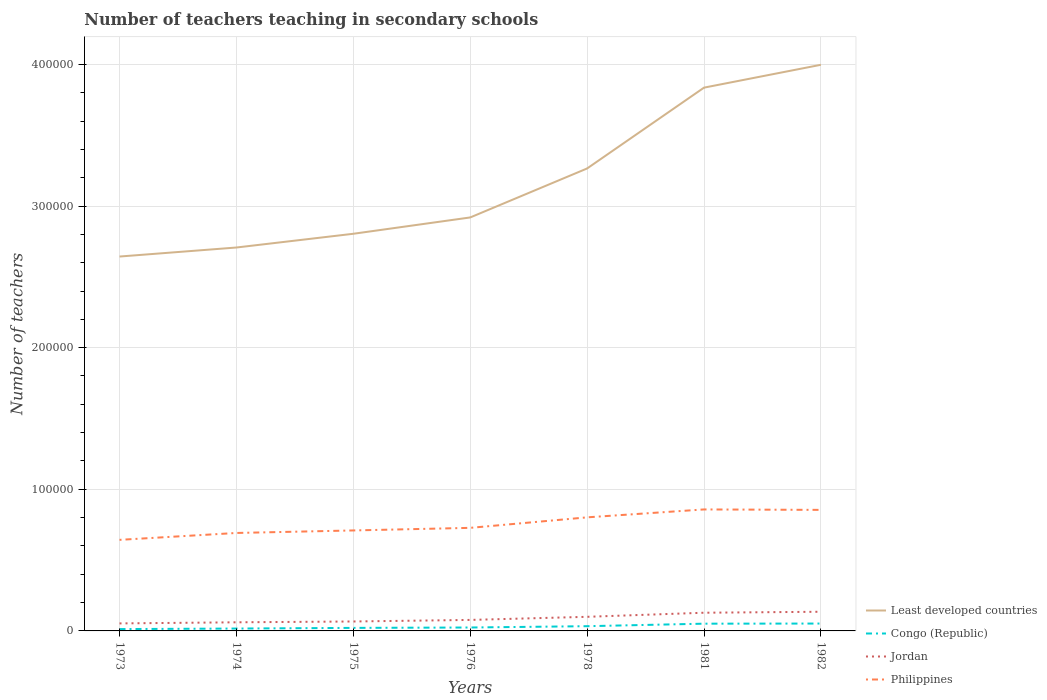Is the number of lines equal to the number of legend labels?
Provide a short and direct response. Yes. Across all years, what is the maximum number of teachers teaching in secondary schools in Congo (Republic)?
Your response must be concise. 1302. What is the total number of teachers teaching in secondary schools in Least developed countries in the graph?
Give a very brief answer. -1.61e+04. What is the difference between the highest and the second highest number of teachers teaching in secondary schools in Jordan?
Give a very brief answer. 8230. What is the difference between the highest and the lowest number of teachers teaching in secondary schools in Jordan?
Your answer should be very brief. 3. How many lines are there?
Offer a terse response. 4. What is the difference between two consecutive major ticks on the Y-axis?
Make the answer very short. 1.00e+05. Does the graph contain any zero values?
Ensure brevity in your answer.  No. Does the graph contain grids?
Offer a terse response. Yes. Where does the legend appear in the graph?
Provide a succinct answer. Bottom right. How are the legend labels stacked?
Your response must be concise. Vertical. What is the title of the graph?
Your answer should be very brief. Number of teachers teaching in secondary schools. Does "Upper middle income" appear as one of the legend labels in the graph?
Your answer should be compact. No. What is the label or title of the X-axis?
Your answer should be compact. Years. What is the label or title of the Y-axis?
Provide a succinct answer. Number of teachers. What is the Number of teachers of Least developed countries in 1973?
Give a very brief answer. 2.64e+05. What is the Number of teachers of Congo (Republic) in 1973?
Your answer should be compact. 1302. What is the Number of teachers in Jordan in 1973?
Your answer should be compact. 5309. What is the Number of teachers in Philippines in 1973?
Your answer should be compact. 6.43e+04. What is the Number of teachers of Least developed countries in 1974?
Ensure brevity in your answer.  2.71e+05. What is the Number of teachers of Congo (Republic) in 1974?
Offer a terse response. 1681. What is the Number of teachers in Jordan in 1974?
Offer a very short reply. 6088. What is the Number of teachers of Philippines in 1974?
Keep it short and to the point. 6.92e+04. What is the Number of teachers in Least developed countries in 1975?
Your answer should be very brief. 2.80e+05. What is the Number of teachers in Congo (Republic) in 1975?
Offer a terse response. 2143. What is the Number of teachers in Jordan in 1975?
Provide a succinct answer. 6666. What is the Number of teachers in Philippines in 1975?
Your response must be concise. 7.09e+04. What is the Number of teachers in Least developed countries in 1976?
Give a very brief answer. 2.92e+05. What is the Number of teachers in Congo (Republic) in 1976?
Keep it short and to the point. 2413. What is the Number of teachers of Jordan in 1976?
Ensure brevity in your answer.  7768. What is the Number of teachers of Philippines in 1976?
Keep it short and to the point. 7.28e+04. What is the Number of teachers in Least developed countries in 1978?
Offer a very short reply. 3.27e+05. What is the Number of teachers in Congo (Republic) in 1978?
Make the answer very short. 3344. What is the Number of teachers in Jordan in 1978?
Make the answer very short. 9962. What is the Number of teachers in Philippines in 1978?
Your answer should be very brief. 8.02e+04. What is the Number of teachers in Least developed countries in 1981?
Your answer should be compact. 3.84e+05. What is the Number of teachers in Congo (Republic) in 1981?
Give a very brief answer. 5117. What is the Number of teachers in Jordan in 1981?
Your answer should be very brief. 1.28e+04. What is the Number of teachers in Philippines in 1981?
Offer a terse response. 8.58e+04. What is the Number of teachers in Least developed countries in 1982?
Make the answer very short. 4.00e+05. What is the Number of teachers in Congo (Republic) in 1982?
Your answer should be very brief. 5207. What is the Number of teachers of Jordan in 1982?
Your answer should be very brief. 1.35e+04. What is the Number of teachers in Philippines in 1982?
Your response must be concise. 8.55e+04. Across all years, what is the maximum Number of teachers in Least developed countries?
Your answer should be very brief. 4.00e+05. Across all years, what is the maximum Number of teachers in Congo (Republic)?
Ensure brevity in your answer.  5207. Across all years, what is the maximum Number of teachers in Jordan?
Offer a terse response. 1.35e+04. Across all years, what is the maximum Number of teachers of Philippines?
Make the answer very short. 8.58e+04. Across all years, what is the minimum Number of teachers of Least developed countries?
Your response must be concise. 2.64e+05. Across all years, what is the minimum Number of teachers in Congo (Republic)?
Provide a succinct answer. 1302. Across all years, what is the minimum Number of teachers of Jordan?
Your response must be concise. 5309. Across all years, what is the minimum Number of teachers in Philippines?
Make the answer very short. 6.43e+04. What is the total Number of teachers in Least developed countries in the graph?
Provide a short and direct response. 2.22e+06. What is the total Number of teachers of Congo (Republic) in the graph?
Provide a succinct answer. 2.12e+04. What is the total Number of teachers in Jordan in the graph?
Your answer should be very brief. 6.22e+04. What is the total Number of teachers of Philippines in the graph?
Your answer should be compact. 5.29e+05. What is the difference between the Number of teachers in Least developed countries in 1973 and that in 1974?
Keep it short and to the point. -6379.69. What is the difference between the Number of teachers in Congo (Republic) in 1973 and that in 1974?
Ensure brevity in your answer.  -379. What is the difference between the Number of teachers in Jordan in 1973 and that in 1974?
Your answer should be compact. -779. What is the difference between the Number of teachers in Philippines in 1973 and that in 1974?
Give a very brief answer. -4864. What is the difference between the Number of teachers of Least developed countries in 1973 and that in 1975?
Your answer should be compact. -1.61e+04. What is the difference between the Number of teachers in Congo (Republic) in 1973 and that in 1975?
Your response must be concise. -841. What is the difference between the Number of teachers of Jordan in 1973 and that in 1975?
Provide a succinct answer. -1357. What is the difference between the Number of teachers in Philippines in 1973 and that in 1975?
Offer a very short reply. -6644. What is the difference between the Number of teachers in Least developed countries in 1973 and that in 1976?
Make the answer very short. -2.76e+04. What is the difference between the Number of teachers of Congo (Republic) in 1973 and that in 1976?
Provide a succinct answer. -1111. What is the difference between the Number of teachers in Jordan in 1973 and that in 1976?
Provide a short and direct response. -2459. What is the difference between the Number of teachers of Philippines in 1973 and that in 1976?
Provide a succinct answer. -8475. What is the difference between the Number of teachers in Least developed countries in 1973 and that in 1978?
Your answer should be compact. -6.22e+04. What is the difference between the Number of teachers of Congo (Republic) in 1973 and that in 1978?
Ensure brevity in your answer.  -2042. What is the difference between the Number of teachers in Jordan in 1973 and that in 1978?
Offer a terse response. -4653. What is the difference between the Number of teachers of Philippines in 1973 and that in 1978?
Your response must be concise. -1.59e+04. What is the difference between the Number of teachers in Least developed countries in 1973 and that in 1981?
Your response must be concise. -1.19e+05. What is the difference between the Number of teachers of Congo (Republic) in 1973 and that in 1981?
Offer a terse response. -3815. What is the difference between the Number of teachers of Jordan in 1973 and that in 1981?
Your answer should be very brief. -7539. What is the difference between the Number of teachers of Philippines in 1973 and that in 1981?
Keep it short and to the point. -2.15e+04. What is the difference between the Number of teachers of Least developed countries in 1973 and that in 1982?
Your answer should be very brief. -1.35e+05. What is the difference between the Number of teachers of Congo (Republic) in 1973 and that in 1982?
Your answer should be very brief. -3905. What is the difference between the Number of teachers in Jordan in 1973 and that in 1982?
Offer a very short reply. -8230. What is the difference between the Number of teachers in Philippines in 1973 and that in 1982?
Make the answer very short. -2.12e+04. What is the difference between the Number of teachers in Least developed countries in 1974 and that in 1975?
Keep it short and to the point. -9694.94. What is the difference between the Number of teachers in Congo (Republic) in 1974 and that in 1975?
Ensure brevity in your answer.  -462. What is the difference between the Number of teachers in Jordan in 1974 and that in 1975?
Offer a very short reply. -578. What is the difference between the Number of teachers in Philippines in 1974 and that in 1975?
Make the answer very short. -1780. What is the difference between the Number of teachers of Least developed countries in 1974 and that in 1976?
Your answer should be very brief. -2.12e+04. What is the difference between the Number of teachers of Congo (Republic) in 1974 and that in 1976?
Your answer should be compact. -732. What is the difference between the Number of teachers in Jordan in 1974 and that in 1976?
Ensure brevity in your answer.  -1680. What is the difference between the Number of teachers of Philippines in 1974 and that in 1976?
Keep it short and to the point. -3611. What is the difference between the Number of teachers in Least developed countries in 1974 and that in 1978?
Your response must be concise. -5.58e+04. What is the difference between the Number of teachers of Congo (Republic) in 1974 and that in 1978?
Your response must be concise. -1663. What is the difference between the Number of teachers of Jordan in 1974 and that in 1978?
Keep it short and to the point. -3874. What is the difference between the Number of teachers in Philippines in 1974 and that in 1978?
Ensure brevity in your answer.  -1.10e+04. What is the difference between the Number of teachers in Least developed countries in 1974 and that in 1981?
Ensure brevity in your answer.  -1.13e+05. What is the difference between the Number of teachers of Congo (Republic) in 1974 and that in 1981?
Your answer should be compact. -3436. What is the difference between the Number of teachers of Jordan in 1974 and that in 1981?
Offer a terse response. -6760. What is the difference between the Number of teachers of Philippines in 1974 and that in 1981?
Your answer should be compact. -1.66e+04. What is the difference between the Number of teachers of Least developed countries in 1974 and that in 1982?
Provide a succinct answer. -1.29e+05. What is the difference between the Number of teachers in Congo (Republic) in 1974 and that in 1982?
Your answer should be compact. -3526. What is the difference between the Number of teachers in Jordan in 1974 and that in 1982?
Your answer should be compact. -7451. What is the difference between the Number of teachers in Philippines in 1974 and that in 1982?
Ensure brevity in your answer.  -1.63e+04. What is the difference between the Number of teachers of Least developed countries in 1975 and that in 1976?
Offer a very short reply. -1.15e+04. What is the difference between the Number of teachers of Congo (Republic) in 1975 and that in 1976?
Keep it short and to the point. -270. What is the difference between the Number of teachers in Jordan in 1975 and that in 1976?
Your answer should be very brief. -1102. What is the difference between the Number of teachers in Philippines in 1975 and that in 1976?
Your response must be concise. -1831. What is the difference between the Number of teachers of Least developed countries in 1975 and that in 1978?
Offer a terse response. -4.61e+04. What is the difference between the Number of teachers of Congo (Republic) in 1975 and that in 1978?
Your response must be concise. -1201. What is the difference between the Number of teachers in Jordan in 1975 and that in 1978?
Provide a succinct answer. -3296. What is the difference between the Number of teachers in Philippines in 1975 and that in 1978?
Ensure brevity in your answer.  -9245. What is the difference between the Number of teachers of Least developed countries in 1975 and that in 1981?
Offer a terse response. -1.03e+05. What is the difference between the Number of teachers in Congo (Republic) in 1975 and that in 1981?
Provide a succinct answer. -2974. What is the difference between the Number of teachers in Jordan in 1975 and that in 1981?
Your answer should be compact. -6182. What is the difference between the Number of teachers in Philippines in 1975 and that in 1981?
Ensure brevity in your answer.  -1.48e+04. What is the difference between the Number of teachers in Least developed countries in 1975 and that in 1982?
Provide a short and direct response. -1.19e+05. What is the difference between the Number of teachers in Congo (Republic) in 1975 and that in 1982?
Your answer should be compact. -3064. What is the difference between the Number of teachers of Jordan in 1975 and that in 1982?
Your response must be concise. -6873. What is the difference between the Number of teachers in Philippines in 1975 and that in 1982?
Make the answer very short. -1.45e+04. What is the difference between the Number of teachers of Least developed countries in 1976 and that in 1978?
Ensure brevity in your answer.  -3.46e+04. What is the difference between the Number of teachers in Congo (Republic) in 1976 and that in 1978?
Offer a terse response. -931. What is the difference between the Number of teachers in Jordan in 1976 and that in 1978?
Give a very brief answer. -2194. What is the difference between the Number of teachers of Philippines in 1976 and that in 1978?
Provide a short and direct response. -7414. What is the difference between the Number of teachers of Least developed countries in 1976 and that in 1981?
Make the answer very short. -9.17e+04. What is the difference between the Number of teachers of Congo (Republic) in 1976 and that in 1981?
Offer a very short reply. -2704. What is the difference between the Number of teachers of Jordan in 1976 and that in 1981?
Your response must be concise. -5080. What is the difference between the Number of teachers of Philippines in 1976 and that in 1981?
Give a very brief answer. -1.30e+04. What is the difference between the Number of teachers of Least developed countries in 1976 and that in 1982?
Ensure brevity in your answer.  -1.08e+05. What is the difference between the Number of teachers of Congo (Republic) in 1976 and that in 1982?
Ensure brevity in your answer.  -2794. What is the difference between the Number of teachers in Jordan in 1976 and that in 1982?
Provide a succinct answer. -5771. What is the difference between the Number of teachers of Philippines in 1976 and that in 1982?
Keep it short and to the point. -1.27e+04. What is the difference between the Number of teachers of Least developed countries in 1978 and that in 1981?
Make the answer very short. -5.71e+04. What is the difference between the Number of teachers in Congo (Republic) in 1978 and that in 1981?
Give a very brief answer. -1773. What is the difference between the Number of teachers in Jordan in 1978 and that in 1981?
Make the answer very short. -2886. What is the difference between the Number of teachers of Philippines in 1978 and that in 1981?
Provide a short and direct response. -5587. What is the difference between the Number of teachers of Least developed countries in 1978 and that in 1982?
Offer a terse response. -7.32e+04. What is the difference between the Number of teachers of Congo (Republic) in 1978 and that in 1982?
Ensure brevity in your answer.  -1863. What is the difference between the Number of teachers in Jordan in 1978 and that in 1982?
Keep it short and to the point. -3577. What is the difference between the Number of teachers in Philippines in 1978 and that in 1982?
Your answer should be compact. -5273. What is the difference between the Number of teachers of Least developed countries in 1981 and that in 1982?
Give a very brief answer. -1.61e+04. What is the difference between the Number of teachers in Congo (Republic) in 1981 and that in 1982?
Make the answer very short. -90. What is the difference between the Number of teachers of Jordan in 1981 and that in 1982?
Provide a short and direct response. -691. What is the difference between the Number of teachers of Philippines in 1981 and that in 1982?
Ensure brevity in your answer.  314. What is the difference between the Number of teachers of Least developed countries in 1973 and the Number of teachers of Congo (Republic) in 1974?
Provide a succinct answer. 2.63e+05. What is the difference between the Number of teachers in Least developed countries in 1973 and the Number of teachers in Jordan in 1974?
Provide a succinct answer. 2.58e+05. What is the difference between the Number of teachers in Least developed countries in 1973 and the Number of teachers in Philippines in 1974?
Offer a very short reply. 1.95e+05. What is the difference between the Number of teachers of Congo (Republic) in 1973 and the Number of teachers of Jordan in 1974?
Provide a succinct answer. -4786. What is the difference between the Number of teachers of Congo (Republic) in 1973 and the Number of teachers of Philippines in 1974?
Make the answer very short. -6.79e+04. What is the difference between the Number of teachers in Jordan in 1973 and the Number of teachers in Philippines in 1974?
Keep it short and to the point. -6.39e+04. What is the difference between the Number of teachers in Least developed countries in 1973 and the Number of teachers in Congo (Republic) in 1975?
Your response must be concise. 2.62e+05. What is the difference between the Number of teachers of Least developed countries in 1973 and the Number of teachers of Jordan in 1975?
Make the answer very short. 2.58e+05. What is the difference between the Number of teachers in Least developed countries in 1973 and the Number of teachers in Philippines in 1975?
Give a very brief answer. 1.93e+05. What is the difference between the Number of teachers of Congo (Republic) in 1973 and the Number of teachers of Jordan in 1975?
Your response must be concise. -5364. What is the difference between the Number of teachers of Congo (Republic) in 1973 and the Number of teachers of Philippines in 1975?
Your answer should be compact. -6.96e+04. What is the difference between the Number of teachers of Jordan in 1973 and the Number of teachers of Philippines in 1975?
Make the answer very short. -6.56e+04. What is the difference between the Number of teachers in Least developed countries in 1973 and the Number of teachers in Congo (Republic) in 1976?
Your answer should be very brief. 2.62e+05. What is the difference between the Number of teachers of Least developed countries in 1973 and the Number of teachers of Jordan in 1976?
Your answer should be very brief. 2.57e+05. What is the difference between the Number of teachers in Least developed countries in 1973 and the Number of teachers in Philippines in 1976?
Provide a short and direct response. 1.92e+05. What is the difference between the Number of teachers of Congo (Republic) in 1973 and the Number of teachers of Jordan in 1976?
Your answer should be compact. -6466. What is the difference between the Number of teachers in Congo (Republic) in 1973 and the Number of teachers in Philippines in 1976?
Your answer should be compact. -7.15e+04. What is the difference between the Number of teachers of Jordan in 1973 and the Number of teachers of Philippines in 1976?
Your answer should be compact. -6.75e+04. What is the difference between the Number of teachers of Least developed countries in 1973 and the Number of teachers of Congo (Republic) in 1978?
Make the answer very short. 2.61e+05. What is the difference between the Number of teachers in Least developed countries in 1973 and the Number of teachers in Jordan in 1978?
Ensure brevity in your answer.  2.54e+05. What is the difference between the Number of teachers of Least developed countries in 1973 and the Number of teachers of Philippines in 1978?
Make the answer very short. 1.84e+05. What is the difference between the Number of teachers in Congo (Republic) in 1973 and the Number of teachers in Jordan in 1978?
Offer a very short reply. -8660. What is the difference between the Number of teachers in Congo (Republic) in 1973 and the Number of teachers in Philippines in 1978?
Offer a terse response. -7.89e+04. What is the difference between the Number of teachers in Jordan in 1973 and the Number of teachers in Philippines in 1978?
Give a very brief answer. -7.49e+04. What is the difference between the Number of teachers of Least developed countries in 1973 and the Number of teachers of Congo (Republic) in 1981?
Make the answer very short. 2.59e+05. What is the difference between the Number of teachers in Least developed countries in 1973 and the Number of teachers in Jordan in 1981?
Ensure brevity in your answer.  2.52e+05. What is the difference between the Number of teachers in Least developed countries in 1973 and the Number of teachers in Philippines in 1981?
Provide a succinct answer. 1.79e+05. What is the difference between the Number of teachers in Congo (Republic) in 1973 and the Number of teachers in Jordan in 1981?
Give a very brief answer. -1.15e+04. What is the difference between the Number of teachers of Congo (Republic) in 1973 and the Number of teachers of Philippines in 1981?
Ensure brevity in your answer.  -8.45e+04. What is the difference between the Number of teachers of Jordan in 1973 and the Number of teachers of Philippines in 1981?
Ensure brevity in your answer.  -8.05e+04. What is the difference between the Number of teachers in Least developed countries in 1973 and the Number of teachers in Congo (Republic) in 1982?
Make the answer very short. 2.59e+05. What is the difference between the Number of teachers of Least developed countries in 1973 and the Number of teachers of Jordan in 1982?
Ensure brevity in your answer.  2.51e+05. What is the difference between the Number of teachers of Least developed countries in 1973 and the Number of teachers of Philippines in 1982?
Provide a succinct answer. 1.79e+05. What is the difference between the Number of teachers of Congo (Republic) in 1973 and the Number of teachers of Jordan in 1982?
Ensure brevity in your answer.  -1.22e+04. What is the difference between the Number of teachers in Congo (Republic) in 1973 and the Number of teachers in Philippines in 1982?
Provide a short and direct response. -8.42e+04. What is the difference between the Number of teachers of Jordan in 1973 and the Number of teachers of Philippines in 1982?
Give a very brief answer. -8.02e+04. What is the difference between the Number of teachers in Least developed countries in 1974 and the Number of teachers in Congo (Republic) in 1975?
Give a very brief answer. 2.69e+05. What is the difference between the Number of teachers in Least developed countries in 1974 and the Number of teachers in Jordan in 1975?
Your response must be concise. 2.64e+05. What is the difference between the Number of teachers of Least developed countries in 1974 and the Number of teachers of Philippines in 1975?
Give a very brief answer. 2.00e+05. What is the difference between the Number of teachers in Congo (Republic) in 1974 and the Number of teachers in Jordan in 1975?
Keep it short and to the point. -4985. What is the difference between the Number of teachers in Congo (Republic) in 1974 and the Number of teachers in Philippines in 1975?
Ensure brevity in your answer.  -6.93e+04. What is the difference between the Number of teachers in Jordan in 1974 and the Number of teachers in Philippines in 1975?
Provide a succinct answer. -6.49e+04. What is the difference between the Number of teachers in Least developed countries in 1974 and the Number of teachers in Congo (Republic) in 1976?
Your answer should be compact. 2.68e+05. What is the difference between the Number of teachers of Least developed countries in 1974 and the Number of teachers of Jordan in 1976?
Provide a succinct answer. 2.63e+05. What is the difference between the Number of teachers of Least developed countries in 1974 and the Number of teachers of Philippines in 1976?
Provide a succinct answer. 1.98e+05. What is the difference between the Number of teachers in Congo (Republic) in 1974 and the Number of teachers in Jordan in 1976?
Your answer should be compact. -6087. What is the difference between the Number of teachers in Congo (Republic) in 1974 and the Number of teachers in Philippines in 1976?
Make the answer very short. -7.11e+04. What is the difference between the Number of teachers in Jordan in 1974 and the Number of teachers in Philippines in 1976?
Offer a very short reply. -6.67e+04. What is the difference between the Number of teachers in Least developed countries in 1974 and the Number of teachers in Congo (Republic) in 1978?
Ensure brevity in your answer.  2.67e+05. What is the difference between the Number of teachers in Least developed countries in 1974 and the Number of teachers in Jordan in 1978?
Keep it short and to the point. 2.61e+05. What is the difference between the Number of teachers in Least developed countries in 1974 and the Number of teachers in Philippines in 1978?
Offer a very short reply. 1.91e+05. What is the difference between the Number of teachers of Congo (Republic) in 1974 and the Number of teachers of Jordan in 1978?
Make the answer very short. -8281. What is the difference between the Number of teachers of Congo (Republic) in 1974 and the Number of teachers of Philippines in 1978?
Give a very brief answer. -7.85e+04. What is the difference between the Number of teachers in Jordan in 1974 and the Number of teachers in Philippines in 1978?
Keep it short and to the point. -7.41e+04. What is the difference between the Number of teachers of Least developed countries in 1974 and the Number of teachers of Congo (Republic) in 1981?
Give a very brief answer. 2.66e+05. What is the difference between the Number of teachers of Least developed countries in 1974 and the Number of teachers of Jordan in 1981?
Your answer should be compact. 2.58e+05. What is the difference between the Number of teachers in Least developed countries in 1974 and the Number of teachers in Philippines in 1981?
Keep it short and to the point. 1.85e+05. What is the difference between the Number of teachers of Congo (Republic) in 1974 and the Number of teachers of Jordan in 1981?
Give a very brief answer. -1.12e+04. What is the difference between the Number of teachers of Congo (Republic) in 1974 and the Number of teachers of Philippines in 1981?
Your response must be concise. -8.41e+04. What is the difference between the Number of teachers of Jordan in 1974 and the Number of teachers of Philippines in 1981?
Your answer should be very brief. -7.97e+04. What is the difference between the Number of teachers in Least developed countries in 1974 and the Number of teachers in Congo (Republic) in 1982?
Ensure brevity in your answer.  2.66e+05. What is the difference between the Number of teachers in Least developed countries in 1974 and the Number of teachers in Jordan in 1982?
Your answer should be compact. 2.57e+05. What is the difference between the Number of teachers of Least developed countries in 1974 and the Number of teachers of Philippines in 1982?
Offer a terse response. 1.85e+05. What is the difference between the Number of teachers of Congo (Republic) in 1974 and the Number of teachers of Jordan in 1982?
Give a very brief answer. -1.19e+04. What is the difference between the Number of teachers of Congo (Republic) in 1974 and the Number of teachers of Philippines in 1982?
Your answer should be very brief. -8.38e+04. What is the difference between the Number of teachers in Jordan in 1974 and the Number of teachers in Philippines in 1982?
Provide a succinct answer. -7.94e+04. What is the difference between the Number of teachers in Least developed countries in 1975 and the Number of teachers in Congo (Republic) in 1976?
Offer a very short reply. 2.78e+05. What is the difference between the Number of teachers in Least developed countries in 1975 and the Number of teachers in Jordan in 1976?
Offer a very short reply. 2.73e+05. What is the difference between the Number of teachers of Least developed countries in 1975 and the Number of teachers of Philippines in 1976?
Make the answer very short. 2.08e+05. What is the difference between the Number of teachers in Congo (Republic) in 1975 and the Number of teachers in Jordan in 1976?
Offer a very short reply. -5625. What is the difference between the Number of teachers of Congo (Republic) in 1975 and the Number of teachers of Philippines in 1976?
Your answer should be compact. -7.06e+04. What is the difference between the Number of teachers of Jordan in 1975 and the Number of teachers of Philippines in 1976?
Offer a terse response. -6.61e+04. What is the difference between the Number of teachers of Least developed countries in 1975 and the Number of teachers of Congo (Republic) in 1978?
Ensure brevity in your answer.  2.77e+05. What is the difference between the Number of teachers in Least developed countries in 1975 and the Number of teachers in Jordan in 1978?
Your answer should be compact. 2.70e+05. What is the difference between the Number of teachers of Least developed countries in 1975 and the Number of teachers of Philippines in 1978?
Your response must be concise. 2.00e+05. What is the difference between the Number of teachers of Congo (Republic) in 1975 and the Number of teachers of Jordan in 1978?
Provide a short and direct response. -7819. What is the difference between the Number of teachers in Congo (Republic) in 1975 and the Number of teachers in Philippines in 1978?
Ensure brevity in your answer.  -7.80e+04. What is the difference between the Number of teachers of Jordan in 1975 and the Number of teachers of Philippines in 1978?
Make the answer very short. -7.35e+04. What is the difference between the Number of teachers of Least developed countries in 1975 and the Number of teachers of Congo (Republic) in 1981?
Make the answer very short. 2.75e+05. What is the difference between the Number of teachers in Least developed countries in 1975 and the Number of teachers in Jordan in 1981?
Ensure brevity in your answer.  2.68e+05. What is the difference between the Number of teachers in Least developed countries in 1975 and the Number of teachers in Philippines in 1981?
Offer a very short reply. 1.95e+05. What is the difference between the Number of teachers in Congo (Republic) in 1975 and the Number of teachers in Jordan in 1981?
Provide a short and direct response. -1.07e+04. What is the difference between the Number of teachers in Congo (Republic) in 1975 and the Number of teachers in Philippines in 1981?
Your answer should be very brief. -8.36e+04. What is the difference between the Number of teachers of Jordan in 1975 and the Number of teachers of Philippines in 1981?
Give a very brief answer. -7.91e+04. What is the difference between the Number of teachers of Least developed countries in 1975 and the Number of teachers of Congo (Republic) in 1982?
Give a very brief answer. 2.75e+05. What is the difference between the Number of teachers of Least developed countries in 1975 and the Number of teachers of Jordan in 1982?
Offer a terse response. 2.67e+05. What is the difference between the Number of teachers of Least developed countries in 1975 and the Number of teachers of Philippines in 1982?
Provide a short and direct response. 1.95e+05. What is the difference between the Number of teachers in Congo (Republic) in 1975 and the Number of teachers in Jordan in 1982?
Offer a terse response. -1.14e+04. What is the difference between the Number of teachers in Congo (Republic) in 1975 and the Number of teachers in Philippines in 1982?
Offer a very short reply. -8.33e+04. What is the difference between the Number of teachers in Jordan in 1975 and the Number of teachers in Philippines in 1982?
Keep it short and to the point. -7.88e+04. What is the difference between the Number of teachers of Least developed countries in 1976 and the Number of teachers of Congo (Republic) in 1978?
Offer a terse response. 2.89e+05. What is the difference between the Number of teachers of Least developed countries in 1976 and the Number of teachers of Jordan in 1978?
Make the answer very short. 2.82e+05. What is the difference between the Number of teachers of Least developed countries in 1976 and the Number of teachers of Philippines in 1978?
Your answer should be very brief. 2.12e+05. What is the difference between the Number of teachers in Congo (Republic) in 1976 and the Number of teachers in Jordan in 1978?
Your response must be concise. -7549. What is the difference between the Number of teachers of Congo (Republic) in 1976 and the Number of teachers of Philippines in 1978?
Offer a very short reply. -7.78e+04. What is the difference between the Number of teachers in Jordan in 1976 and the Number of teachers in Philippines in 1978?
Provide a succinct answer. -7.24e+04. What is the difference between the Number of teachers in Least developed countries in 1976 and the Number of teachers in Congo (Republic) in 1981?
Offer a terse response. 2.87e+05. What is the difference between the Number of teachers of Least developed countries in 1976 and the Number of teachers of Jordan in 1981?
Give a very brief answer. 2.79e+05. What is the difference between the Number of teachers in Least developed countries in 1976 and the Number of teachers in Philippines in 1981?
Provide a succinct answer. 2.06e+05. What is the difference between the Number of teachers in Congo (Republic) in 1976 and the Number of teachers in Jordan in 1981?
Keep it short and to the point. -1.04e+04. What is the difference between the Number of teachers in Congo (Republic) in 1976 and the Number of teachers in Philippines in 1981?
Offer a terse response. -8.34e+04. What is the difference between the Number of teachers of Jordan in 1976 and the Number of teachers of Philippines in 1981?
Offer a terse response. -7.80e+04. What is the difference between the Number of teachers in Least developed countries in 1976 and the Number of teachers in Congo (Republic) in 1982?
Give a very brief answer. 2.87e+05. What is the difference between the Number of teachers in Least developed countries in 1976 and the Number of teachers in Jordan in 1982?
Your answer should be compact. 2.78e+05. What is the difference between the Number of teachers in Least developed countries in 1976 and the Number of teachers in Philippines in 1982?
Give a very brief answer. 2.06e+05. What is the difference between the Number of teachers of Congo (Republic) in 1976 and the Number of teachers of Jordan in 1982?
Keep it short and to the point. -1.11e+04. What is the difference between the Number of teachers in Congo (Republic) in 1976 and the Number of teachers in Philippines in 1982?
Offer a very short reply. -8.31e+04. What is the difference between the Number of teachers of Jordan in 1976 and the Number of teachers of Philippines in 1982?
Offer a very short reply. -7.77e+04. What is the difference between the Number of teachers in Least developed countries in 1978 and the Number of teachers in Congo (Republic) in 1981?
Give a very brief answer. 3.21e+05. What is the difference between the Number of teachers of Least developed countries in 1978 and the Number of teachers of Jordan in 1981?
Your response must be concise. 3.14e+05. What is the difference between the Number of teachers of Least developed countries in 1978 and the Number of teachers of Philippines in 1981?
Ensure brevity in your answer.  2.41e+05. What is the difference between the Number of teachers in Congo (Republic) in 1978 and the Number of teachers in Jordan in 1981?
Provide a succinct answer. -9504. What is the difference between the Number of teachers in Congo (Republic) in 1978 and the Number of teachers in Philippines in 1981?
Provide a succinct answer. -8.24e+04. What is the difference between the Number of teachers in Jordan in 1978 and the Number of teachers in Philippines in 1981?
Your answer should be very brief. -7.58e+04. What is the difference between the Number of teachers in Least developed countries in 1978 and the Number of teachers in Congo (Republic) in 1982?
Offer a very short reply. 3.21e+05. What is the difference between the Number of teachers in Least developed countries in 1978 and the Number of teachers in Jordan in 1982?
Give a very brief answer. 3.13e+05. What is the difference between the Number of teachers in Least developed countries in 1978 and the Number of teachers in Philippines in 1982?
Keep it short and to the point. 2.41e+05. What is the difference between the Number of teachers in Congo (Republic) in 1978 and the Number of teachers in Jordan in 1982?
Offer a very short reply. -1.02e+04. What is the difference between the Number of teachers of Congo (Republic) in 1978 and the Number of teachers of Philippines in 1982?
Your answer should be compact. -8.21e+04. What is the difference between the Number of teachers of Jordan in 1978 and the Number of teachers of Philippines in 1982?
Make the answer very short. -7.55e+04. What is the difference between the Number of teachers in Least developed countries in 1981 and the Number of teachers in Congo (Republic) in 1982?
Your answer should be compact. 3.78e+05. What is the difference between the Number of teachers of Least developed countries in 1981 and the Number of teachers of Jordan in 1982?
Provide a short and direct response. 3.70e+05. What is the difference between the Number of teachers of Least developed countries in 1981 and the Number of teachers of Philippines in 1982?
Offer a very short reply. 2.98e+05. What is the difference between the Number of teachers of Congo (Republic) in 1981 and the Number of teachers of Jordan in 1982?
Offer a very short reply. -8422. What is the difference between the Number of teachers of Congo (Republic) in 1981 and the Number of teachers of Philippines in 1982?
Keep it short and to the point. -8.03e+04. What is the difference between the Number of teachers of Jordan in 1981 and the Number of teachers of Philippines in 1982?
Offer a terse response. -7.26e+04. What is the average Number of teachers of Least developed countries per year?
Provide a succinct answer. 3.17e+05. What is the average Number of teachers of Congo (Republic) per year?
Give a very brief answer. 3029.57. What is the average Number of teachers of Jordan per year?
Give a very brief answer. 8882.86. What is the average Number of teachers of Philippines per year?
Make the answer very short. 7.55e+04. In the year 1973, what is the difference between the Number of teachers of Least developed countries and Number of teachers of Congo (Republic)?
Make the answer very short. 2.63e+05. In the year 1973, what is the difference between the Number of teachers of Least developed countries and Number of teachers of Jordan?
Offer a very short reply. 2.59e+05. In the year 1973, what is the difference between the Number of teachers in Least developed countries and Number of teachers in Philippines?
Offer a very short reply. 2.00e+05. In the year 1973, what is the difference between the Number of teachers of Congo (Republic) and Number of teachers of Jordan?
Keep it short and to the point. -4007. In the year 1973, what is the difference between the Number of teachers in Congo (Republic) and Number of teachers in Philippines?
Offer a terse response. -6.30e+04. In the year 1973, what is the difference between the Number of teachers of Jordan and Number of teachers of Philippines?
Keep it short and to the point. -5.90e+04. In the year 1974, what is the difference between the Number of teachers of Least developed countries and Number of teachers of Congo (Republic)?
Your answer should be very brief. 2.69e+05. In the year 1974, what is the difference between the Number of teachers of Least developed countries and Number of teachers of Jordan?
Keep it short and to the point. 2.65e+05. In the year 1974, what is the difference between the Number of teachers of Least developed countries and Number of teachers of Philippines?
Your answer should be compact. 2.02e+05. In the year 1974, what is the difference between the Number of teachers of Congo (Republic) and Number of teachers of Jordan?
Your response must be concise. -4407. In the year 1974, what is the difference between the Number of teachers in Congo (Republic) and Number of teachers in Philippines?
Your response must be concise. -6.75e+04. In the year 1974, what is the difference between the Number of teachers in Jordan and Number of teachers in Philippines?
Make the answer very short. -6.31e+04. In the year 1975, what is the difference between the Number of teachers of Least developed countries and Number of teachers of Congo (Republic)?
Ensure brevity in your answer.  2.78e+05. In the year 1975, what is the difference between the Number of teachers of Least developed countries and Number of teachers of Jordan?
Ensure brevity in your answer.  2.74e+05. In the year 1975, what is the difference between the Number of teachers in Least developed countries and Number of teachers in Philippines?
Provide a short and direct response. 2.09e+05. In the year 1975, what is the difference between the Number of teachers of Congo (Republic) and Number of teachers of Jordan?
Provide a succinct answer. -4523. In the year 1975, what is the difference between the Number of teachers of Congo (Republic) and Number of teachers of Philippines?
Ensure brevity in your answer.  -6.88e+04. In the year 1975, what is the difference between the Number of teachers of Jordan and Number of teachers of Philippines?
Give a very brief answer. -6.43e+04. In the year 1976, what is the difference between the Number of teachers of Least developed countries and Number of teachers of Congo (Republic)?
Your answer should be very brief. 2.90e+05. In the year 1976, what is the difference between the Number of teachers in Least developed countries and Number of teachers in Jordan?
Provide a short and direct response. 2.84e+05. In the year 1976, what is the difference between the Number of teachers in Least developed countries and Number of teachers in Philippines?
Provide a succinct answer. 2.19e+05. In the year 1976, what is the difference between the Number of teachers of Congo (Republic) and Number of teachers of Jordan?
Your response must be concise. -5355. In the year 1976, what is the difference between the Number of teachers of Congo (Republic) and Number of teachers of Philippines?
Make the answer very short. -7.04e+04. In the year 1976, what is the difference between the Number of teachers in Jordan and Number of teachers in Philippines?
Keep it short and to the point. -6.50e+04. In the year 1978, what is the difference between the Number of teachers of Least developed countries and Number of teachers of Congo (Republic)?
Offer a very short reply. 3.23e+05. In the year 1978, what is the difference between the Number of teachers of Least developed countries and Number of teachers of Jordan?
Make the answer very short. 3.17e+05. In the year 1978, what is the difference between the Number of teachers in Least developed countries and Number of teachers in Philippines?
Give a very brief answer. 2.46e+05. In the year 1978, what is the difference between the Number of teachers in Congo (Republic) and Number of teachers in Jordan?
Your answer should be very brief. -6618. In the year 1978, what is the difference between the Number of teachers in Congo (Republic) and Number of teachers in Philippines?
Provide a succinct answer. -7.68e+04. In the year 1978, what is the difference between the Number of teachers in Jordan and Number of teachers in Philippines?
Give a very brief answer. -7.02e+04. In the year 1981, what is the difference between the Number of teachers of Least developed countries and Number of teachers of Congo (Republic)?
Ensure brevity in your answer.  3.78e+05. In the year 1981, what is the difference between the Number of teachers of Least developed countries and Number of teachers of Jordan?
Make the answer very short. 3.71e+05. In the year 1981, what is the difference between the Number of teachers in Least developed countries and Number of teachers in Philippines?
Your response must be concise. 2.98e+05. In the year 1981, what is the difference between the Number of teachers of Congo (Republic) and Number of teachers of Jordan?
Provide a short and direct response. -7731. In the year 1981, what is the difference between the Number of teachers of Congo (Republic) and Number of teachers of Philippines?
Your answer should be compact. -8.07e+04. In the year 1981, what is the difference between the Number of teachers of Jordan and Number of teachers of Philippines?
Give a very brief answer. -7.29e+04. In the year 1982, what is the difference between the Number of teachers of Least developed countries and Number of teachers of Congo (Republic)?
Offer a very short reply. 3.95e+05. In the year 1982, what is the difference between the Number of teachers of Least developed countries and Number of teachers of Jordan?
Keep it short and to the point. 3.86e+05. In the year 1982, what is the difference between the Number of teachers of Least developed countries and Number of teachers of Philippines?
Keep it short and to the point. 3.14e+05. In the year 1982, what is the difference between the Number of teachers of Congo (Republic) and Number of teachers of Jordan?
Provide a succinct answer. -8332. In the year 1982, what is the difference between the Number of teachers in Congo (Republic) and Number of teachers in Philippines?
Your answer should be very brief. -8.03e+04. In the year 1982, what is the difference between the Number of teachers in Jordan and Number of teachers in Philippines?
Make the answer very short. -7.19e+04. What is the ratio of the Number of teachers in Least developed countries in 1973 to that in 1974?
Keep it short and to the point. 0.98. What is the ratio of the Number of teachers in Congo (Republic) in 1973 to that in 1974?
Provide a short and direct response. 0.77. What is the ratio of the Number of teachers of Jordan in 1973 to that in 1974?
Your answer should be compact. 0.87. What is the ratio of the Number of teachers in Philippines in 1973 to that in 1974?
Your answer should be compact. 0.93. What is the ratio of the Number of teachers of Least developed countries in 1973 to that in 1975?
Ensure brevity in your answer.  0.94. What is the ratio of the Number of teachers in Congo (Republic) in 1973 to that in 1975?
Provide a succinct answer. 0.61. What is the ratio of the Number of teachers in Jordan in 1973 to that in 1975?
Offer a very short reply. 0.8. What is the ratio of the Number of teachers in Philippines in 1973 to that in 1975?
Ensure brevity in your answer.  0.91. What is the ratio of the Number of teachers of Least developed countries in 1973 to that in 1976?
Your answer should be very brief. 0.91. What is the ratio of the Number of teachers in Congo (Republic) in 1973 to that in 1976?
Your response must be concise. 0.54. What is the ratio of the Number of teachers in Jordan in 1973 to that in 1976?
Offer a terse response. 0.68. What is the ratio of the Number of teachers of Philippines in 1973 to that in 1976?
Offer a very short reply. 0.88. What is the ratio of the Number of teachers in Least developed countries in 1973 to that in 1978?
Keep it short and to the point. 0.81. What is the ratio of the Number of teachers of Congo (Republic) in 1973 to that in 1978?
Give a very brief answer. 0.39. What is the ratio of the Number of teachers in Jordan in 1973 to that in 1978?
Provide a succinct answer. 0.53. What is the ratio of the Number of teachers of Philippines in 1973 to that in 1978?
Give a very brief answer. 0.8. What is the ratio of the Number of teachers of Least developed countries in 1973 to that in 1981?
Ensure brevity in your answer.  0.69. What is the ratio of the Number of teachers in Congo (Republic) in 1973 to that in 1981?
Offer a terse response. 0.25. What is the ratio of the Number of teachers of Jordan in 1973 to that in 1981?
Your answer should be very brief. 0.41. What is the ratio of the Number of teachers of Philippines in 1973 to that in 1981?
Your answer should be very brief. 0.75. What is the ratio of the Number of teachers of Least developed countries in 1973 to that in 1982?
Make the answer very short. 0.66. What is the ratio of the Number of teachers in Jordan in 1973 to that in 1982?
Your response must be concise. 0.39. What is the ratio of the Number of teachers of Philippines in 1973 to that in 1982?
Make the answer very short. 0.75. What is the ratio of the Number of teachers of Least developed countries in 1974 to that in 1975?
Provide a short and direct response. 0.97. What is the ratio of the Number of teachers in Congo (Republic) in 1974 to that in 1975?
Provide a succinct answer. 0.78. What is the ratio of the Number of teachers of Jordan in 1974 to that in 1975?
Your answer should be compact. 0.91. What is the ratio of the Number of teachers of Philippines in 1974 to that in 1975?
Your answer should be very brief. 0.97. What is the ratio of the Number of teachers in Least developed countries in 1974 to that in 1976?
Your response must be concise. 0.93. What is the ratio of the Number of teachers in Congo (Republic) in 1974 to that in 1976?
Offer a terse response. 0.7. What is the ratio of the Number of teachers of Jordan in 1974 to that in 1976?
Ensure brevity in your answer.  0.78. What is the ratio of the Number of teachers of Philippines in 1974 to that in 1976?
Your response must be concise. 0.95. What is the ratio of the Number of teachers of Least developed countries in 1974 to that in 1978?
Give a very brief answer. 0.83. What is the ratio of the Number of teachers in Congo (Republic) in 1974 to that in 1978?
Provide a succinct answer. 0.5. What is the ratio of the Number of teachers in Jordan in 1974 to that in 1978?
Keep it short and to the point. 0.61. What is the ratio of the Number of teachers in Philippines in 1974 to that in 1978?
Your answer should be compact. 0.86. What is the ratio of the Number of teachers in Least developed countries in 1974 to that in 1981?
Offer a very short reply. 0.71. What is the ratio of the Number of teachers in Congo (Republic) in 1974 to that in 1981?
Provide a short and direct response. 0.33. What is the ratio of the Number of teachers of Jordan in 1974 to that in 1981?
Ensure brevity in your answer.  0.47. What is the ratio of the Number of teachers of Philippines in 1974 to that in 1981?
Offer a terse response. 0.81. What is the ratio of the Number of teachers of Least developed countries in 1974 to that in 1982?
Provide a succinct answer. 0.68. What is the ratio of the Number of teachers in Congo (Republic) in 1974 to that in 1982?
Offer a terse response. 0.32. What is the ratio of the Number of teachers in Jordan in 1974 to that in 1982?
Make the answer very short. 0.45. What is the ratio of the Number of teachers in Philippines in 1974 to that in 1982?
Your response must be concise. 0.81. What is the ratio of the Number of teachers in Least developed countries in 1975 to that in 1976?
Offer a very short reply. 0.96. What is the ratio of the Number of teachers of Congo (Republic) in 1975 to that in 1976?
Provide a succinct answer. 0.89. What is the ratio of the Number of teachers in Jordan in 1975 to that in 1976?
Keep it short and to the point. 0.86. What is the ratio of the Number of teachers of Philippines in 1975 to that in 1976?
Keep it short and to the point. 0.97. What is the ratio of the Number of teachers of Least developed countries in 1975 to that in 1978?
Offer a terse response. 0.86. What is the ratio of the Number of teachers of Congo (Republic) in 1975 to that in 1978?
Provide a succinct answer. 0.64. What is the ratio of the Number of teachers of Jordan in 1975 to that in 1978?
Offer a terse response. 0.67. What is the ratio of the Number of teachers in Philippines in 1975 to that in 1978?
Give a very brief answer. 0.88. What is the ratio of the Number of teachers of Least developed countries in 1975 to that in 1981?
Give a very brief answer. 0.73. What is the ratio of the Number of teachers of Congo (Republic) in 1975 to that in 1981?
Your answer should be compact. 0.42. What is the ratio of the Number of teachers in Jordan in 1975 to that in 1981?
Ensure brevity in your answer.  0.52. What is the ratio of the Number of teachers of Philippines in 1975 to that in 1981?
Provide a short and direct response. 0.83. What is the ratio of the Number of teachers of Least developed countries in 1975 to that in 1982?
Give a very brief answer. 0.7. What is the ratio of the Number of teachers of Congo (Republic) in 1975 to that in 1982?
Your response must be concise. 0.41. What is the ratio of the Number of teachers in Jordan in 1975 to that in 1982?
Your answer should be compact. 0.49. What is the ratio of the Number of teachers of Philippines in 1975 to that in 1982?
Offer a very short reply. 0.83. What is the ratio of the Number of teachers of Least developed countries in 1976 to that in 1978?
Give a very brief answer. 0.89. What is the ratio of the Number of teachers in Congo (Republic) in 1976 to that in 1978?
Give a very brief answer. 0.72. What is the ratio of the Number of teachers of Jordan in 1976 to that in 1978?
Make the answer very short. 0.78. What is the ratio of the Number of teachers of Philippines in 1976 to that in 1978?
Keep it short and to the point. 0.91. What is the ratio of the Number of teachers in Least developed countries in 1976 to that in 1981?
Keep it short and to the point. 0.76. What is the ratio of the Number of teachers of Congo (Republic) in 1976 to that in 1981?
Provide a short and direct response. 0.47. What is the ratio of the Number of teachers in Jordan in 1976 to that in 1981?
Keep it short and to the point. 0.6. What is the ratio of the Number of teachers of Philippines in 1976 to that in 1981?
Make the answer very short. 0.85. What is the ratio of the Number of teachers in Least developed countries in 1976 to that in 1982?
Offer a very short reply. 0.73. What is the ratio of the Number of teachers of Congo (Republic) in 1976 to that in 1982?
Your answer should be very brief. 0.46. What is the ratio of the Number of teachers in Jordan in 1976 to that in 1982?
Make the answer very short. 0.57. What is the ratio of the Number of teachers of Philippines in 1976 to that in 1982?
Your answer should be compact. 0.85. What is the ratio of the Number of teachers in Least developed countries in 1978 to that in 1981?
Offer a very short reply. 0.85. What is the ratio of the Number of teachers of Congo (Republic) in 1978 to that in 1981?
Offer a terse response. 0.65. What is the ratio of the Number of teachers in Jordan in 1978 to that in 1981?
Ensure brevity in your answer.  0.78. What is the ratio of the Number of teachers of Philippines in 1978 to that in 1981?
Give a very brief answer. 0.93. What is the ratio of the Number of teachers of Least developed countries in 1978 to that in 1982?
Your answer should be compact. 0.82. What is the ratio of the Number of teachers in Congo (Republic) in 1978 to that in 1982?
Your response must be concise. 0.64. What is the ratio of the Number of teachers of Jordan in 1978 to that in 1982?
Your answer should be compact. 0.74. What is the ratio of the Number of teachers in Philippines in 1978 to that in 1982?
Offer a terse response. 0.94. What is the ratio of the Number of teachers in Least developed countries in 1981 to that in 1982?
Keep it short and to the point. 0.96. What is the ratio of the Number of teachers in Congo (Republic) in 1981 to that in 1982?
Offer a very short reply. 0.98. What is the ratio of the Number of teachers of Jordan in 1981 to that in 1982?
Your answer should be very brief. 0.95. What is the ratio of the Number of teachers in Philippines in 1981 to that in 1982?
Ensure brevity in your answer.  1. What is the difference between the highest and the second highest Number of teachers in Least developed countries?
Your response must be concise. 1.61e+04. What is the difference between the highest and the second highest Number of teachers of Jordan?
Provide a short and direct response. 691. What is the difference between the highest and the second highest Number of teachers of Philippines?
Your response must be concise. 314. What is the difference between the highest and the lowest Number of teachers in Least developed countries?
Keep it short and to the point. 1.35e+05. What is the difference between the highest and the lowest Number of teachers of Congo (Republic)?
Provide a succinct answer. 3905. What is the difference between the highest and the lowest Number of teachers of Jordan?
Offer a terse response. 8230. What is the difference between the highest and the lowest Number of teachers of Philippines?
Make the answer very short. 2.15e+04. 